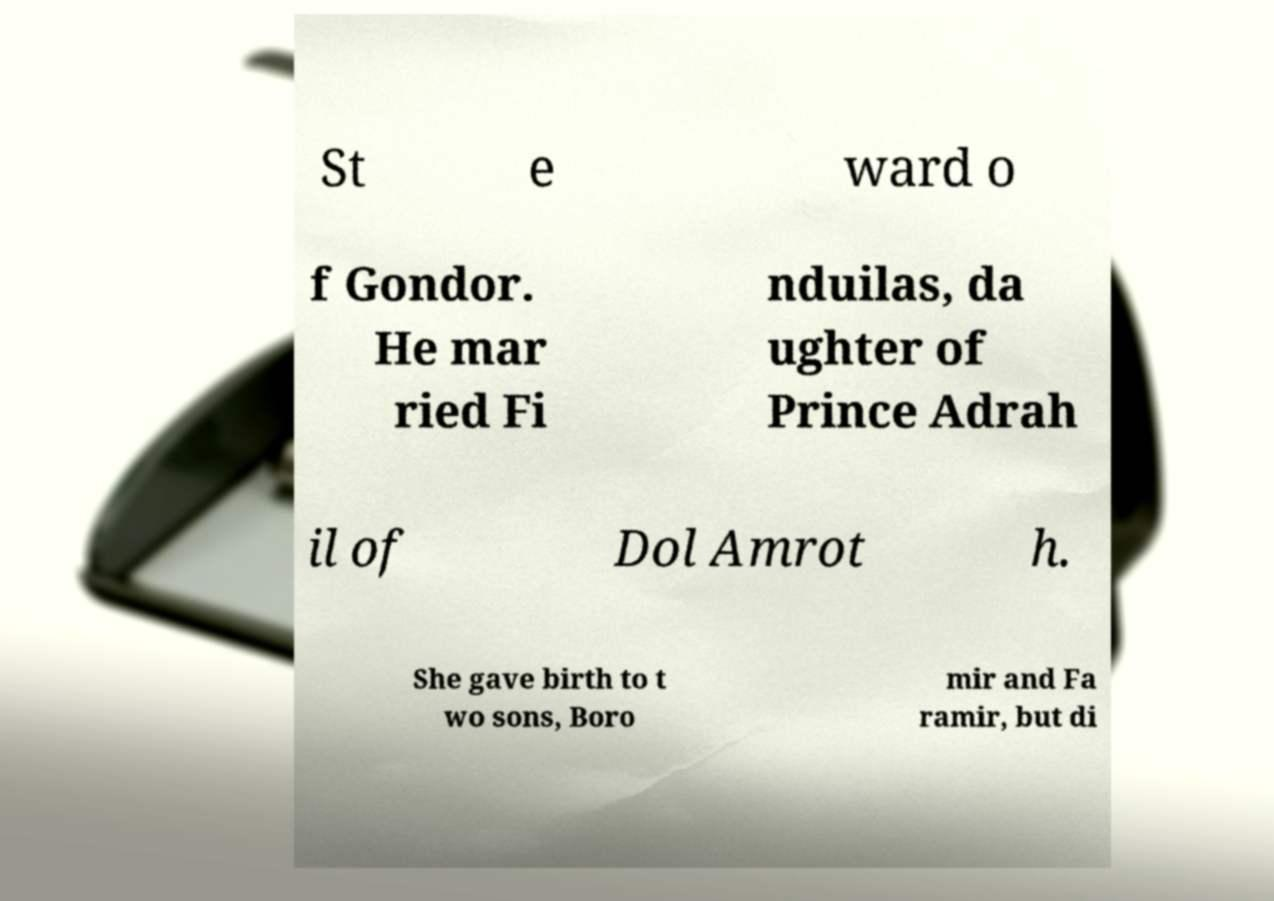Please identify and transcribe the text found in this image. St e ward o f Gondor. He mar ried Fi nduilas, da ughter of Prince Adrah il of Dol Amrot h. She gave birth to t wo sons, Boro mir and Fa ramir, but di 